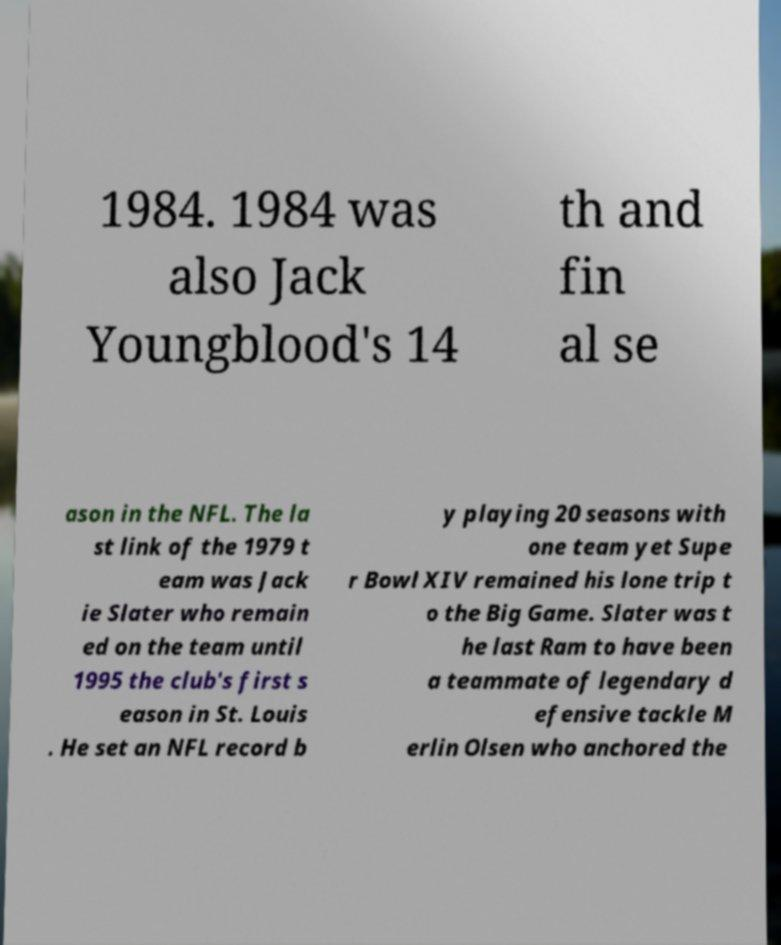What messages or text are displayed in this image? I need them in a readable, typed format. 1984. 1984 was also Jack Youngblood's 14 th and fin al se ason in the NFL. The la st link of the 1979 t eam was Jack ie Slater who remain ed on the team until 1995 the club's first s eason in St. Louis . He set an NFL record b y playing 20 seasons with one team yet Supe r Bowl XIV remained his lone trip t o the Big Game. Slater was t he last Ram to have been a teammate of legendary d efensive tackle M erlin Olsen who anchored the 